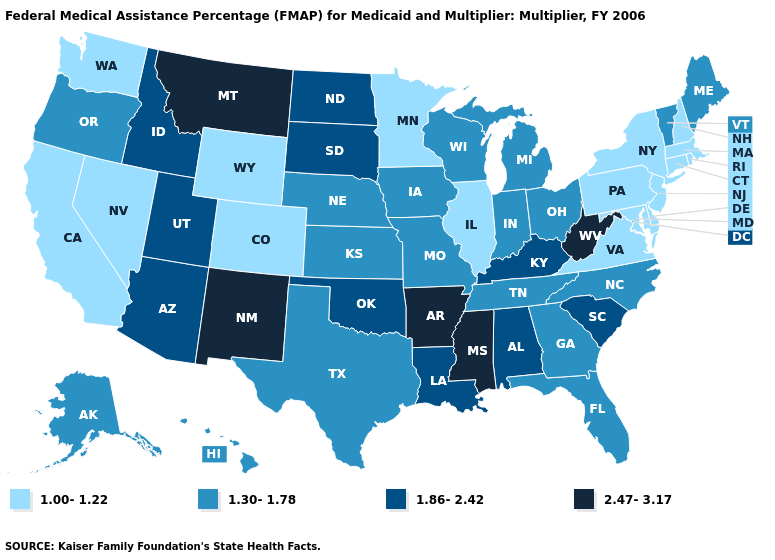What is the value of Connecticut?
Be succinct. 1.00-1.22. What is the highest value in states that border Utah?
Answer briefly. 2.47-3.17. What is the value of Maryland?
Be succinct. 1.00-1.22. What is the value of Washington?
Answer briefly. 1.00-1.22. Does South Dakota have the highest value in the MidWest?
Answer briefly. Yes. Does Nebraska have the same value as Colorado?
Be succinct. No. What is the highest value in the USA?
Quick response, please. 2.47-3.17. What is the highest value in the MidWest ?
Quick response, please. 1.86-2.42. Among the states that border Wisconsin , which have the lowest value?
Quick response, please. Illinois, Minnesota. What is the value of Vermont?
Quick response, please. 1.30-1.78. How many symbols are there in the legend?
Be succinct. 4. Name the states that have a value in the range 1.86-2.42?
Short answer required. Alabama, Arizona, Idaho, Kentucky, Louisiana, North Dakota, Oklahoma, South Carolina, South Dakota, Utah. Among the states that border Illinois , which have the lowest value?
Write a very short answer. Indiana, Iowa, Missouri, Wisconsin. Name the states that have a value in the range 2.47-3.17?
Short answer required. Arkansas, Mississippi, Montana, New Mexico, West Virginia. 